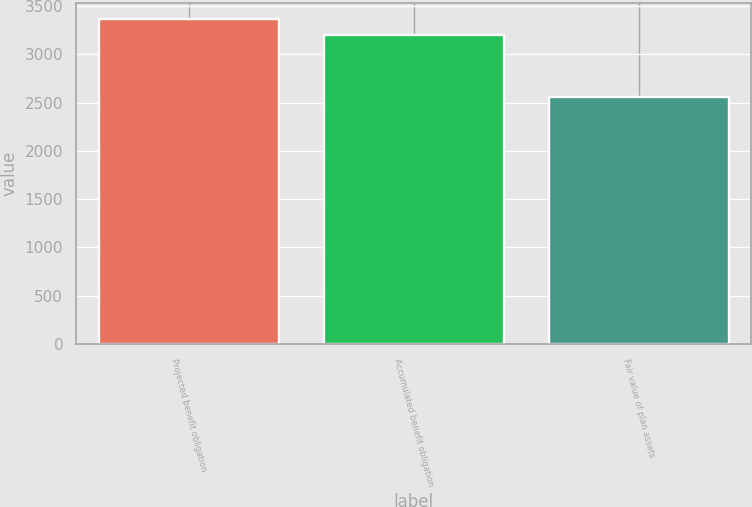<chart> <loc_0><loc_0><loc_500><loc_500><bar_chart><fcel>Projected benefit obligation<fcel>Accumulated benefit obligation<fcel>Fair value of plan assets<nl><fcel>3367<fcel>3204<fcel>2563<nl></chart> 